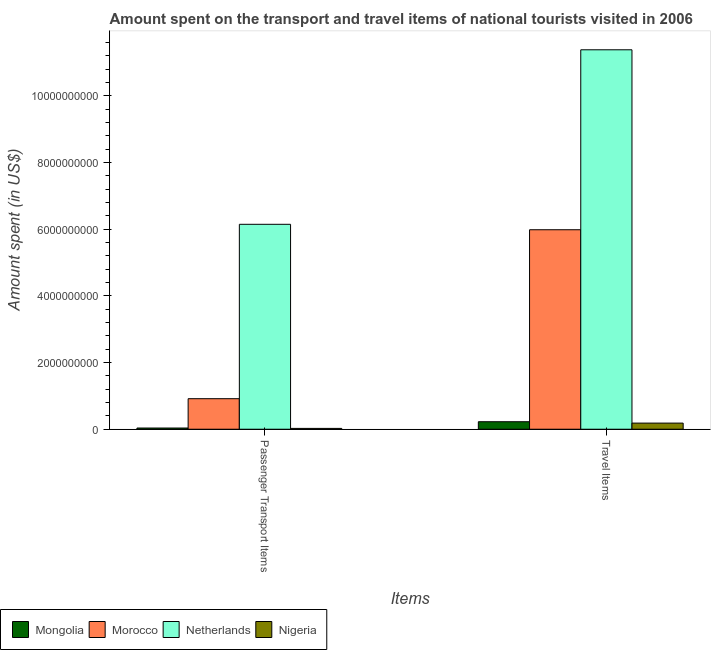How many different coloured bars are there?
Your answer should be very brief. 4. Are the number of bars per tick equal to the number of legend labels?
Make the answer very short. Yes. What is the label of the 1st group of bars from the left?
Give a very brief answer. Passenger Transport Items. What is the amount spent on passenger transport items in Mongolia?
Give a very brief answer. 3.60e+07. Across all countries, what is the maximum amount spent in travel items?
Give a very brief answer. 1.14e+1. Across all countries, what is the minimum amount spent in travel items?
Your answer should be compact. 1.84e+08. In which country was the amount spent in travel items minimum?
Your answer should be compact. Nigeria. What is the total amount spent in travel items in the graph?
Your answer should be compact. 1.78e+1. What is the difference between the amount spent on passenger transport items in Netherlands and that in Nigeria?
Your answer should be very brief. 6.12e+09. What is the difference between the amount spent in travel items in Netherlands and the amount spent on passenger transport items in Mongolia?
Offer a terse response. 1.13e+1. What is the average amount spent in travel items per country?
Offer a terse response. 4.44e+09. What is the difference between the amount spent on passenger transport items and amount spent in travel items in Netherlands?
Ensure brevity in your answer.  -5.24e+09. In how many countries, is the amount spent in travel items greater than 6000000000 US$?
Ensure brevity in your answer.  1. What is the ratio of the amount spent in travel items in Morocco to that in Mongolia?
Give a very brief answer. 26.6. What does the 1st bar from the left in Passenger Transport Items represents?
Make the answer very short. Mongolia. What does the 2nd bar from the right in Passenger Transport Items represents?
Give a very brief answer. Netherlands. How many bars are there?
Provide a short and direct response. 8. Are all the bars in the graph horizontal?
Provide a succinct answer. No. How are the legend labels stacked?
Make the answer very short. Horizontal. What is the title of the graph?
Your response must be concise. Amount spent on the transport and travel items of national tourists visited in 2006. What is the label or title of the X-axis?
Give a very brief answer. Items. What is the label or title of the Y-axis?
Your response must be concise. Amount spent (in US$). What is the Amount spent (in US$) in Mongolia in Passenger Transport Items?
Your answer should be compact. 3.60e+07. What is the Amount spent (in US$) in Morocco in Passenger Transport Items?
Make the answer very short. 9.16e+08. What is the Amount spent (in US$) of Netherlands in Passenger Transport Items?
Provide a short and direct response. 6.15e+09. What is the Amount spent (in US$) in Nigeria in Passenger Transport Items?
Offer a terse response. 2.50e+07. What is the Amount spent (in US$) in Mongolia in Travel Items?
Offer a very short reply. 2.25e+08. What is the Amount spent (in US$) in Morocco in Travel Items?
Give a very brief answer. 5.98e+09. What is the Amount spent (in US$) in Netherlands in Travel Items?
Provide a succinct answer. 1.14e+1. What is the Amount spent (in US$) in Nigeria in Travel Items?
Ensure brevity in your answer.  1.84e+08. Across all Items, what is the maximum Amount spent (in US$) in Mongolia?
Offer a very short reply. 2.25e+08. Across all Items, what is the maximum Amount spent (in US$) in Morocco?
Your answer should be compact. 5.98e+09. Across all Items, what is the maximum Amount spent (in US$) of Netherlands?
Give a very brief answer. 1.14e+1. Across all Items, what is the maximum Amount spent (in US$) of Nigeria?
Offer a very short reply. 1.84e+08. Across all Items, what is the minimum Amount spent (in US$) in Mongolia?
Provide a short and direct response. 3.60e+07. Across all Items, what is the minimum Amount spent (in US$) of Morocco?
Your answer should be very brief. 9.16e+08. Across all Items, what is the minimum Amount spent (in US$) in Netherlands?
Your answer should be compact. 6.15e+09. Across all Items, what is the minimum Amount spent (in US$) of Nigeria?
Your answer should be compact. 2.50e+07. What is the total Amount spent (in US$) of Mongolia in the graph?
Your response must be concise. 2.61e+08. What is the total Amount spent (in US$) of Morocco in the graph?
Keep it short and to the point. 6.90e+09. What is the total Amount spent (in US$) in Netherlands in the graph?
Your response must be concise. 1.75e+1. What is the total Amount spent (in US$) of Nigeria in the graph?
Your response must be concise. 2.09e+08. What is the difference between the Amount spent (in US$) of Mongolia in Passenger Transport Items and that in Travel Items?
Your response must be concise. -1.89e+08. What is the difference between the Amount spent (in US$) in Morocco in Passenger Transport Items and that in Travel Items?
Provide a short and direct response. -5.07e+09. What is the difference between the Amount spent (in US$) in Netherlands in Passenger Transport Items and that in Travel Items?
Keep it short and to the point. -5.24e+09. What is the difference between the Amount spent (in US$) in Nigeria in Passenger Transport Items and that in Travel Items?
Make the answer very short. -1.59e+08. What is the difference between the Amount spent (in US$) of Mongolia in Passenger Transport Items and the Amount spent (in US$) of Morocco in Travel Items?
Provide a short and direct response. -5.95e+09. What is the difference between the Amount spent (in US$) of Mongolia in Passenger Transport Items and the Amount spent (in US$) of Netherlands in Travel Items?
Your response must be concise. -1.13e+1. What is the difference between the Amount spent (in US$) in Mongolia in Passenger Transport Items and the Amount spent (in US$) in Nigeria in Travel Items?
Ensure brevity in your answer.  -1.48e+08. What is the difference between the Amount spent (in US$) in Morocco in Passenger Transport Items and the Amount spent (in US$) in Netherlands in Travel Items?
Provide a succinct answer. -1.05e+1. What is the difference between the Amount spent (in US$) of Morocco in Passenger Transport Items and the Amount spent (in US$) of Nigeria in Travel Items?
Provide a succinct answer. 7.32e+08. What is the difference between the Amount spent (in US$) in Netherlands in Passenger Transport Items and the Amount spent (in US$) in Nigeria in Travel Items?
Keep it short and to the point. 5.96e+09. What is the average Amount spent (in US$) in Mongolia per Items?
Give a very brief answer. 1.30e+08. What is the average Amount spent (in US$) in Morocco per Items?
Make the answer very short. 3.45e+09. What is the average Amount spent (in US$) in Netherlands per Items?
Provide a succinct answer. 8.76e+09. What is the average Amount spent (in US$) in Nigeria per Items?
Your response must be concise. 1.04e+08. What is the difference between the Amount spent (in US$) in Mongolia and Amount spent (in US$) in Morocco in Passenger Transport Items?
Your answer should be compact. -8.80e+08. What is the difference between the Amount spent (in US$) in Mongolia and Amount spent (in US$) in Netherlands in Passenger Transport Items?
Your answer should be compact. -6.11e+09. What is the difference between the Amount spent (in US$) in Mongolia and Amount spent (in US$) in Nigeria in Passenger Transport Items?
Provide a short and direct response. 1.10e+07. What is the difference between the Amount spent (in US$) of Morocco and Amount spent (in US$) of Netherlands in Passenger Transport Items?
Your answer should be very brief. -5.23e+09. What is the difference between the Amount spent (in US$) of Morocco and Amount spent (in US$) of Nigeria in Passenger Transport Items?
Provide a short and direct response. 8.91e+08. What is the difference between the Amount spent (in US$) in Netherlands and Amount spent (in US$) in Nigeria in Passenger Transport Items?
Give a very brief answer. 6.12e+09. What is the difference between the Amount spent (in US$) of Mongolia and Amount spent (in US$) of Morocco in Travel Items?
Your answer should be very brief. -5.76e+09. What is the difference between the Amount spent (in US$) in Mongolia and Amount spent (in US$) in Netherlands in Travel Items?
Make the answer very short. -1.12e+1. What is the difference between the Amount spent (in US$) in Mongolia and Amount spent (in US$) in Nigeria in Travel Items?
Provide a short and direct response. 4.10e+07. What is the difference between the Amount spent (in US$) of Morocco and Amount spent (in US$) of Netherlands in Travel Items?
Your answer should be very brief. -5.40e+09. What is the difference between the Amount spent (in US$) of Morocco and Amount spent (in US$) of Nigeria in Travel Items?
Provide a succinct answer. 5.80e+09. What is the difference between the Amount spent (in US$) in Netherlands and Amount spent (in US$) in Nigeria in Travel Items?
Provide a short and direct response. 1.12e+1. What is the ratio of the Amount spent (in US$) in Mongolia in Passenger Transport Items to that in Travel Items?
Make the answer very short. 0.16. What is the ratio of the Amount spent (in US$) in Morocco in Passenger Transport Items to that in Travel Items?
Ensure brevity in your answer.  0.15. What is the ratio of the Amount spent (in US$) in Netherlands in Passenger Transport Items to that in Travel Items?
Keep it short and to the point. 0.54. What is the ratio of the Amount spent (in US$) of Nigeria in Passenger Transport Items to that in Travel Items?
Provide a short and direct response. 0.14. What is the difference between the highest and the second highest Amount spent (in US$) of Mongolia?
Provide a succinct answer. 1.89e+08. What is the difference between the highest and the second highest Amount spent (in US$) in Morocco?
Offer a very short reply. 5.07e+09. What is the difference between the highest and the second highest Amount spent (in US$) in Netherlands?
Offer a very short reply. 5.24e+09. What is the difference between the highest and the second highest Amount spent (in US$) in Nigeria?
Keep it short and to the point. 1.59e+08. What is the difference between the highest and the lowest Amount spent (in US$) of Mongolia?
Make the answer very short. 1.89e+08. What is the difference between the highest and the lowest Amount spent (in US$) of Morocco?
Your response must be concise. 5.07e+09. What is the difference between the highest and the lowest Amount spent (in US$) in Netherlands?
Your answer should be compact. 5.24e+09. What is the difference between the highest and the lowest Amount spent (in US$) of Nigeria?
Keep it short and to the point. 1.59e+08. 